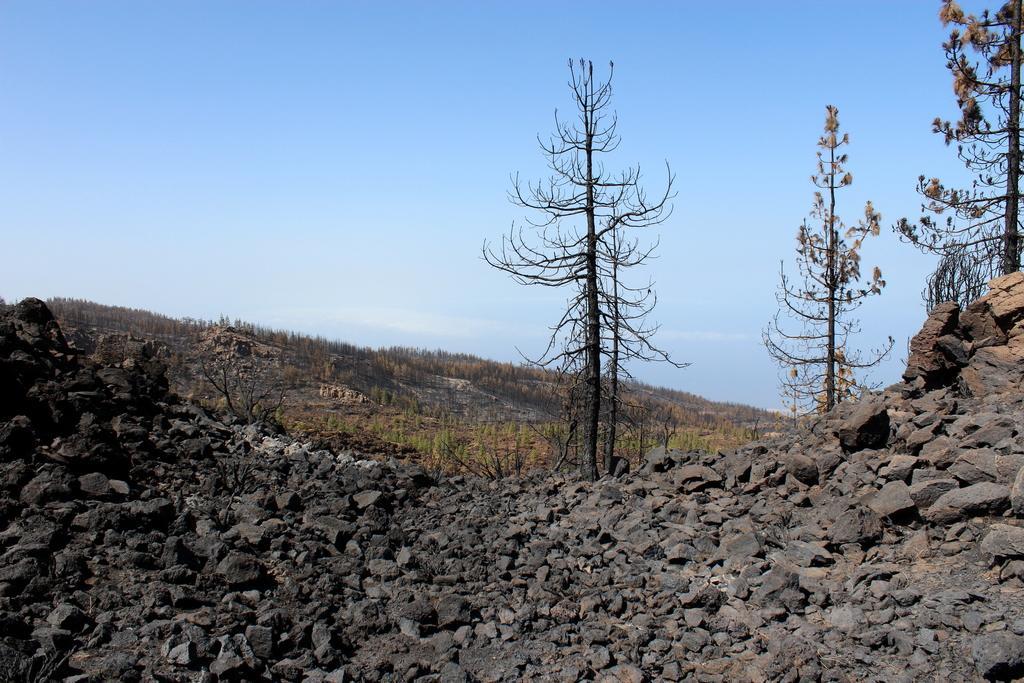How would you summarize this image in a sentence or two? In this image in front there are rocks. In the background of the image there are trees and sky. 